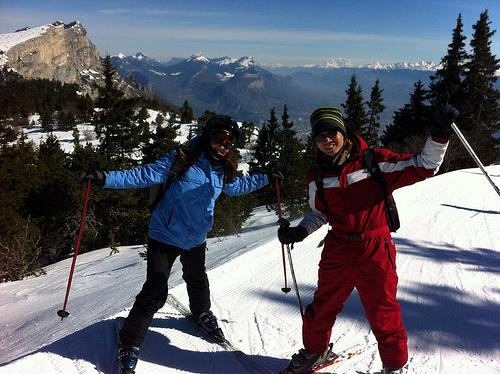In the context of the image, describe the apparel and gear associated with the sport being played. People in the image are wearing ski outfits, safety glasses, helmets, ski caps, and sunglasses, and holding ski poles, which are all associated with skiing. Describe the main activity taking place in this image. People dressed for skiing are standing in the snow, preparing for or enjoying a day of skiing on a snow-covered mountain. Provide a brief overview of the objects and people within this snowy setting. In the image, there are people dressed for skiing, wearing colorful ski outfits and safety gear, standing in snow with ski equipment like ski poles, and surrounded by a snow-covered mountainside and pine trees. What type of weather or season does the image depict? The image depicts a snowy, cold winter season or weather. Identify the dominant color of the shirts worn by people in the image. The dominant colors of the shirts in the image are blue and red. List the types of safety gear being worn by people in the image. Safety gear in the image includes ski caps, helmets, safety glasses, and sunglasses. From the image, describe the landscape and environment where the activities are taking place. The activities are taking place in a winter landscape with snow-covered ground, mountainside, ski tracks in the snow, and pine trees in the background. Mention the presence of any natural elements in the image. Natural elements in the image include snow-covered ground, mountainside, pine trees, and a mountain range in the distance. Estimate the total number of people present in the image. Approximately four people are present in the image. Give a summary of the elements related to the skiing activity in the photograph. In the photo, there are ski tracks in the snow, ski poles, safety gear, and people dressed for skiing with colorful ski outfits. Is there a palm tree in the distance at X:360 Y:70? There are pine trees in the image located at X:349 Y:72, but no palm tree, making this instruction misleading. Can you see a cat sitting on the snow covered ground at X:100 Y:300? There is ground covered in snow at X:90 Y:286 and X:223 Y:267, but there is no cat in the image, making this instruction misleading. Is there a person in a yellow jacket located at X:90 Y:100? There is a person in a blue jacket at X:83 Y:101, but there is no person in a yellow jacket making this instruction misleading. Are there ski tracks located in the sky at X:400 Y:50? There are ski tracks in the snow at X:225 Y:296 and X:415 Y:239, but there are no ski tracks in the sky at the mentioned coordinates, making this instruction misleading. Can you find the person wearing a blue ski cap at X:150 Y:120? There is a person wearing a black and green ski cap at X:298 Y:103, but no person with a blue ski cap, making this instruction misleading. Is the ski pole located at X:200 Y:150 and colored green? The ski pole in the image is red and located at X:49 Y:188, so this instruction is misleading by both location and color. 